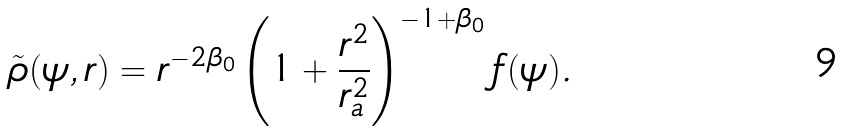Convert formula to latex. <formula><loc_0><loc_0><loc_500><loc_500>\tilde { \rho } ( \psi , r ) = r ^ { - 2 \beta _ { 0 } } \left ( 1 + \frac { r ^ { 2 } } { r _ { a } ^ { 2 } } \right ) ^ { - 1 + \beta _ { 0 } } f ( \psi ) .</formula> 